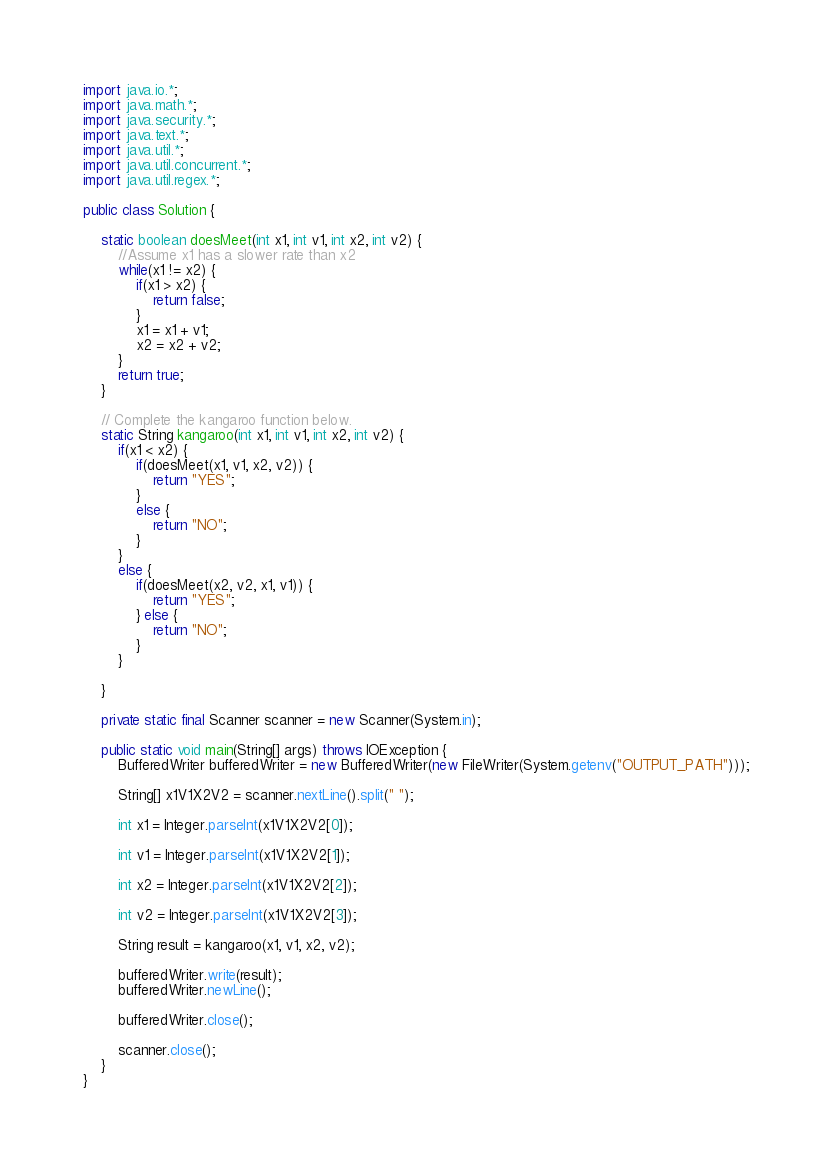<code> <loc_0><loc_0><loc_500><loc_500><_Java_>import java.io.*;
import java.math.*;
import java.security.*;
import java.text.*;
import java.util.*;
import java.util.concurrent.*;
import java.util.regex.*;

public class Solution {
    
    static boolean doesMeet(int x1, int v1, int x2, int v2) {
        //Assume x1 has a slower rate than x2
        while(x1 != x2) {
            if(x1 > x2) {
                return false;
            }
            x1 = x1 + v1;
            x2 = x2 + v2;
        }
        return true;
    }

    // Complete the kangaroo function below.
    static String kangaroo(int x1, int v1, int x2, int v2) {
        if(x1 < x2) {
            if(doesMeet(x1, v1, x2, v2)) {
                return "YES";
            }
            else {
                return "NO";
            }
        }
        else {
            if(doesMeet(x2, v2, x1, v1)) {
                return "YES";
            } else {
                return "NO";
            }
        }

    }

    private static final Scanner scanner = new Scanner(System.in);

    public static void main(String[] args) throws IOException {
        BufferedWriter bufferedWriter = new BufferedWriter(new FileWriter(System.getenv("OUTPUT_PATH")));

        String[] x1V1X2V2 = scanner.nextLine().split(" ");

        int x1 = Integer.parseInt(x1V1X2V2[0]);

        int v1 = Integer.parseInt(x1V1X2V2[1]);

        int x2 = Integer.parseInt(x1V1X2V2[2]);

        int v2 = Integer.parseInt(x1V1X2V2[3]);

        String result = kangaroo(x1, v1, x2, v2);

        bufferedWriter.write(result);
        bufferedWriter.newLine();

        bufferedWriter.close();

        scanner.close();
    }
}</code> 